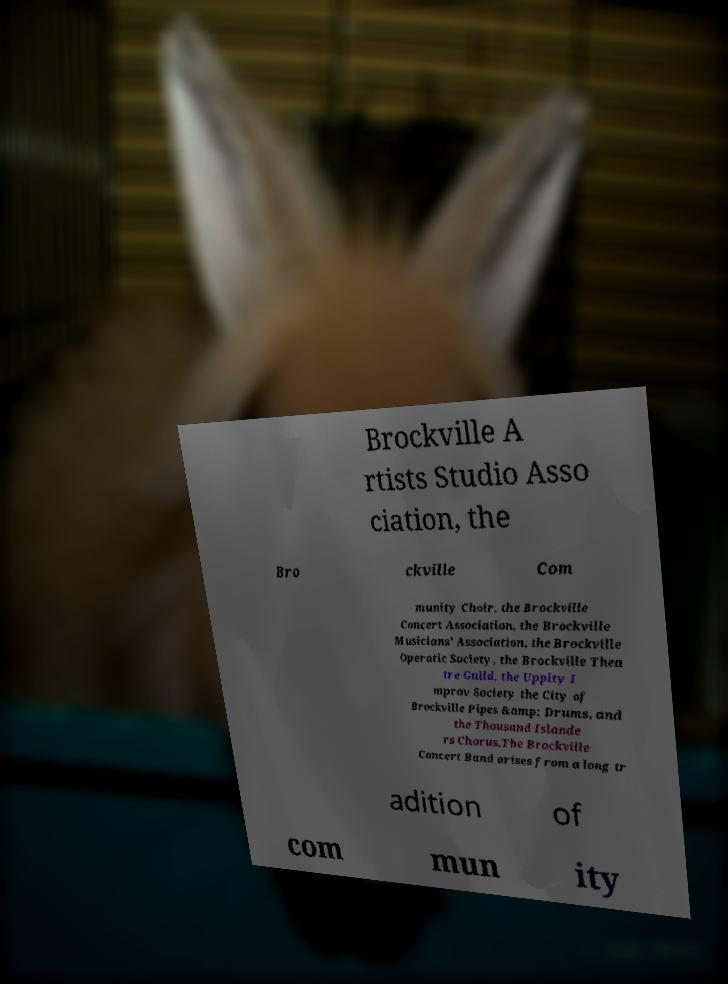Could you extract and type out the text from this image? Brockville A rtists Studio Asso ciation, the Bro ckville Com munity Choir, the Brockville Concert Association, the Brockville Musicians' Association, the Brockville Operatic Society, the Brockville Thea tre Guild, the Uppity I mprov Society the City of Brockville Pipes &amp; Drums, and the Thousand Islande rs Chorus.The Brockville Concert Band arises from a long tr adition of com mun ity 